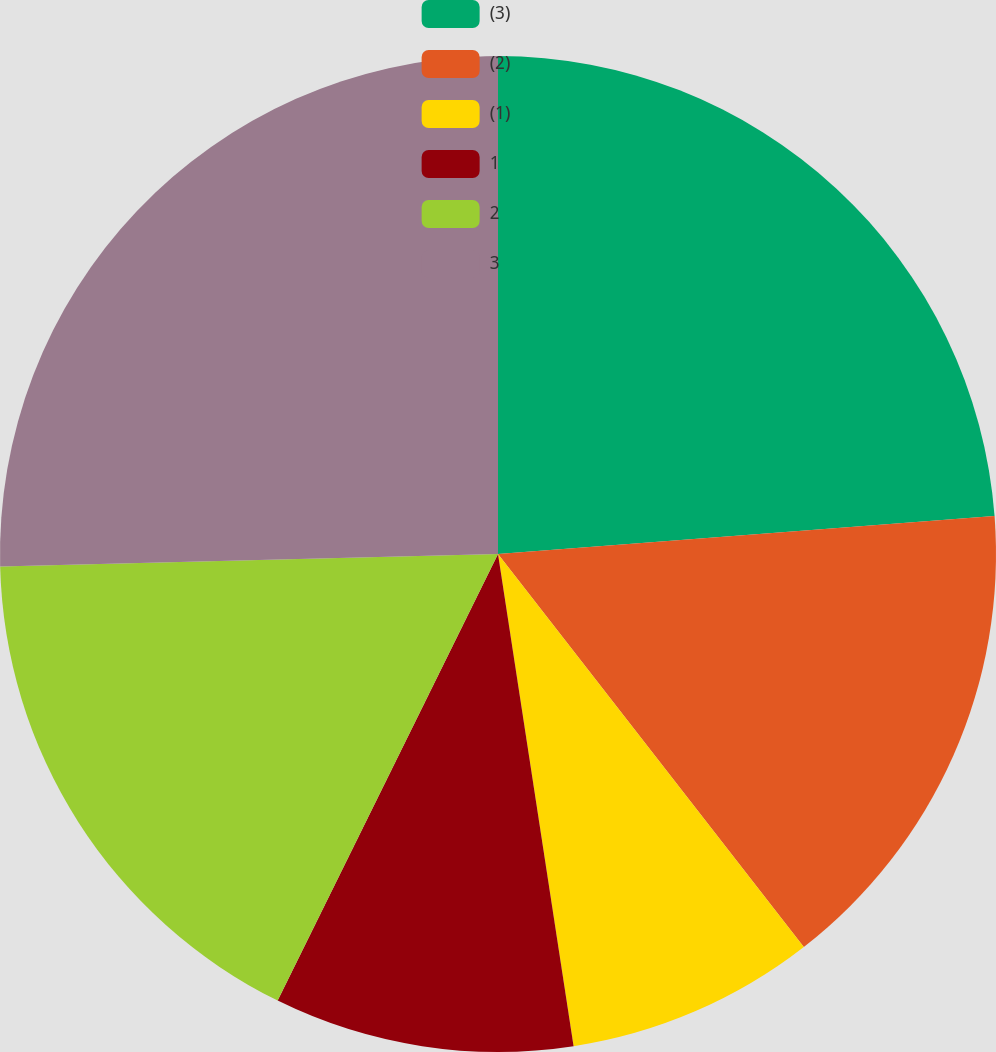<chart> <loc_0><loc_0><loc_500><loc_500><pie_chart><fcel>(3)<fcel>(2)<fcel>(1)<fcel>1<fcel>2<fcel>3<nl><fcel>23.79%<fcel>15.69%<fcel>8.1%<fcel>9.72%<fcel>17.31%<fcel>25.4%<nl></chart> 